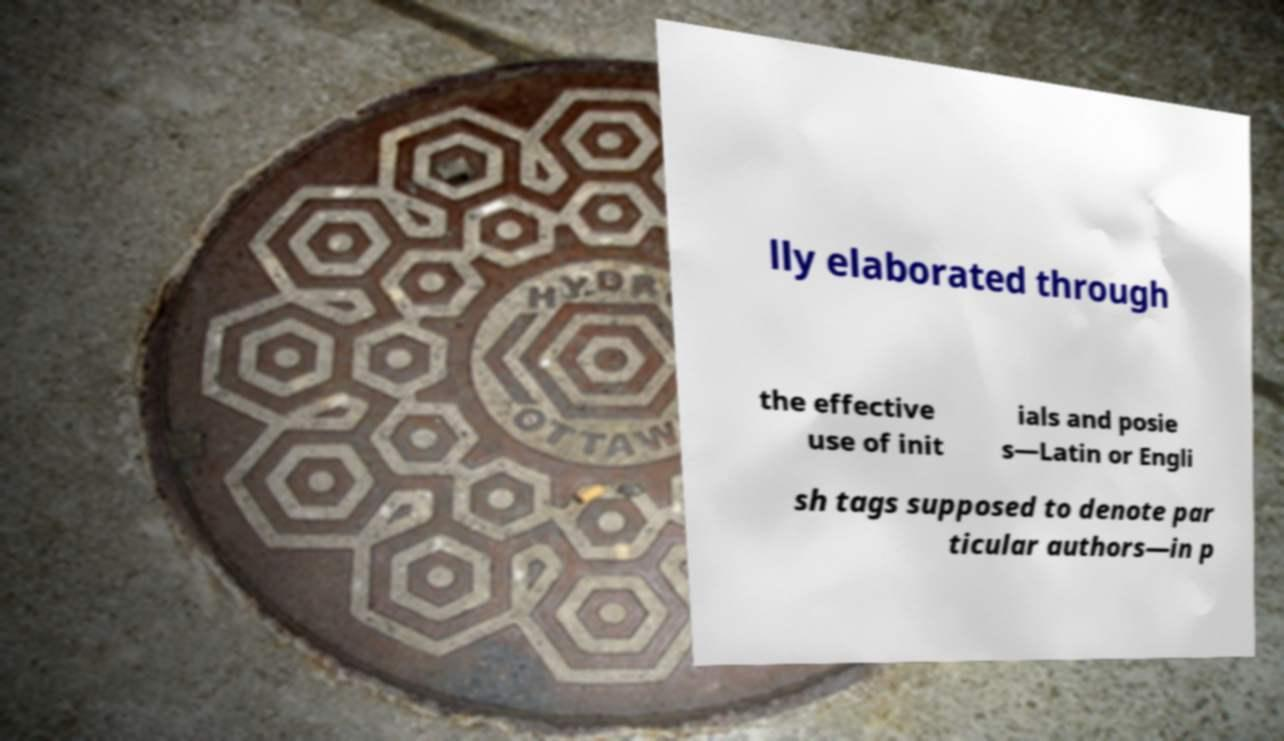There's text embedded in this image that I need extracted. Can you transcribe it verbatim? lly elaborated through the effective use of init ials and posie s—Latin or Engli sh tags supposed to denote par ticular authors—in p 